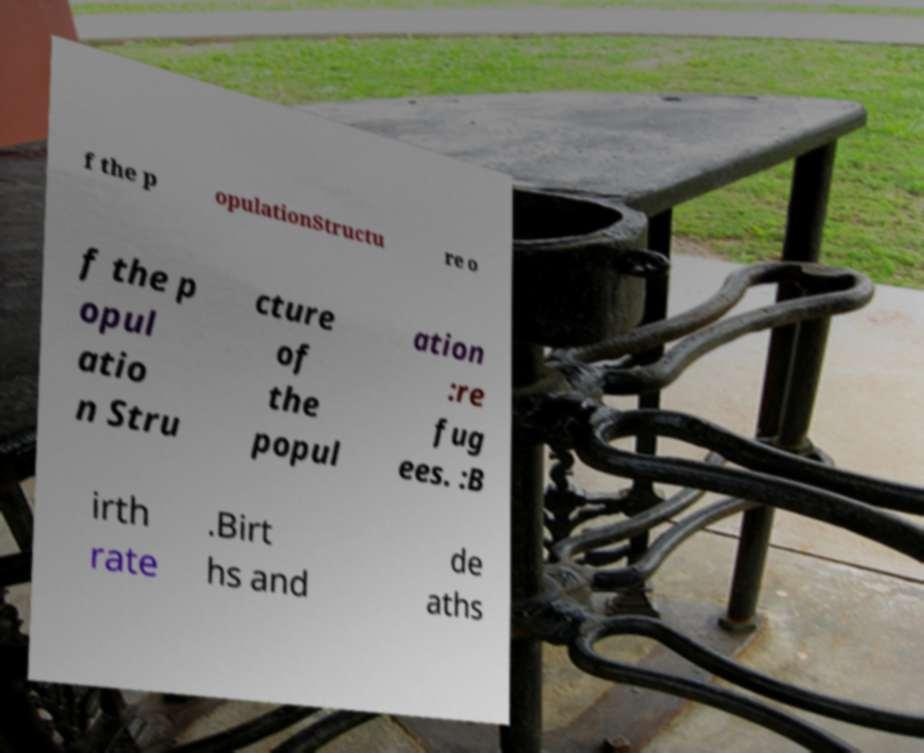Please identify and transcribe the text found in this image. f the p opulationStructu re o f the p opul atio n Stru cture of the popul ation :re fug ees. :B irth rate .Birt hs and de aths 